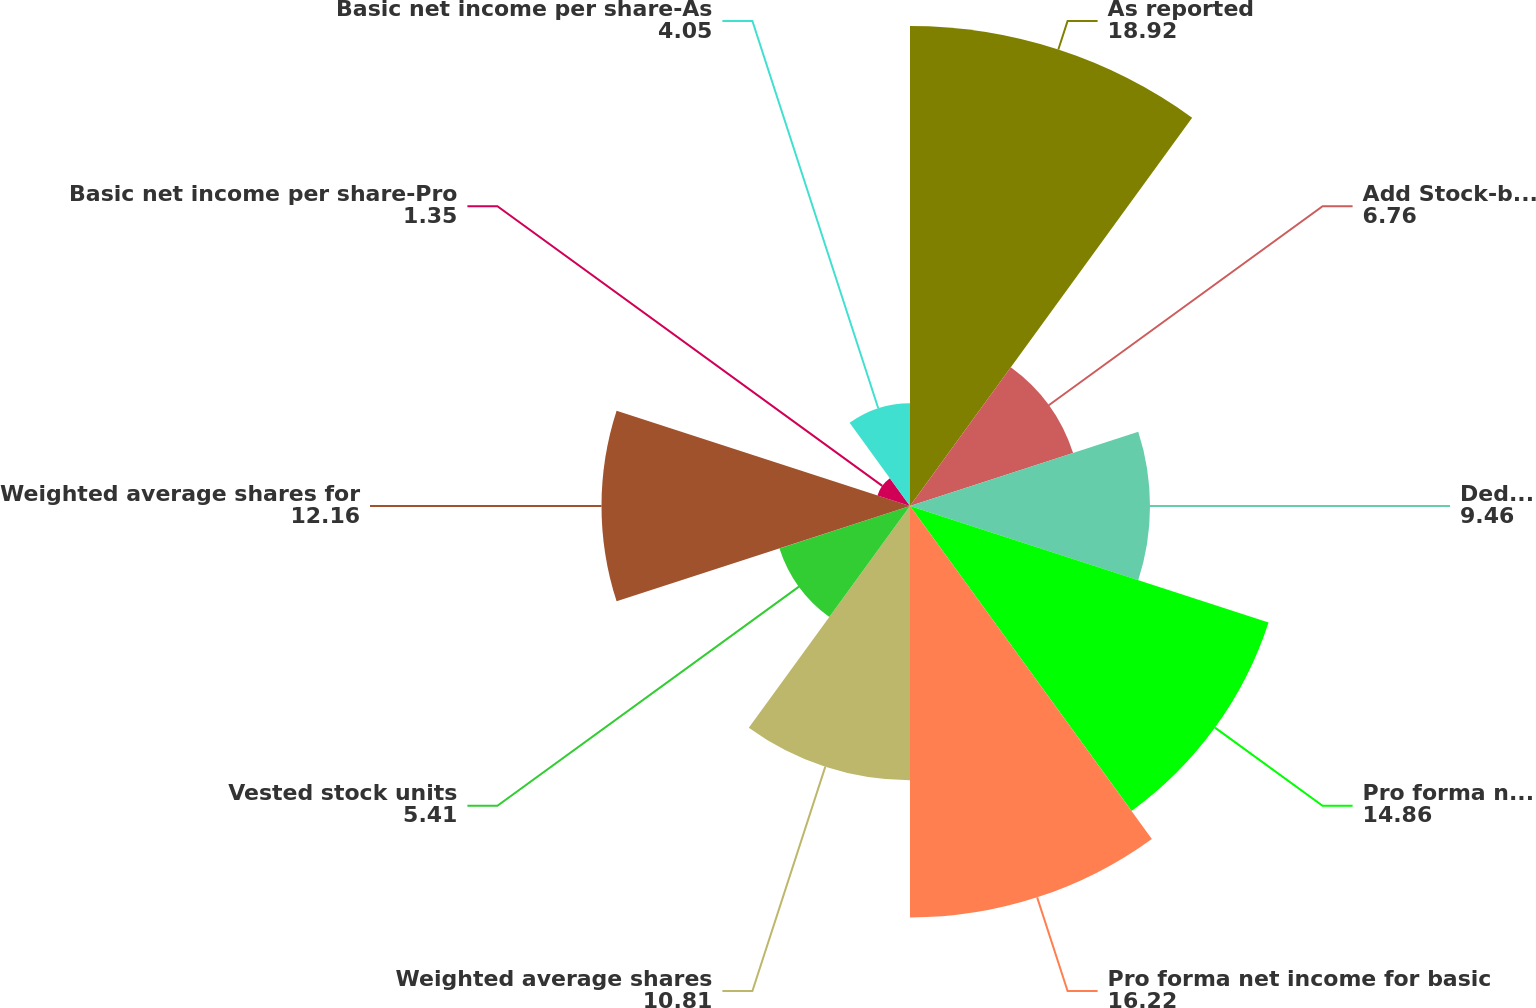Convert chart to OTSL. <chart><loc_0><loc_0><loc_500><loc_500><pie_chart><fcel>As reported<fcel>Add Stock-based employee<fcel>Deduct Total stock-based<fcel>Pro forma net income<fcel>Pro forma net income for basic<fcel>Weighted average shares<fcel>Vested stock units<fcel>Weighted average shares for<fcel>Basic net income per share-Pro<fcel>Basic net income per share-As<nl><fcel>18.92%<fcel>6.76%<fcel>9.46%<fcel>14.86%<fcel>16.22%<fcel>10.81%<fcel>5.41%<fcel>12.16%<fcel>1.35%<fcel>4.05%<nl></chart> 